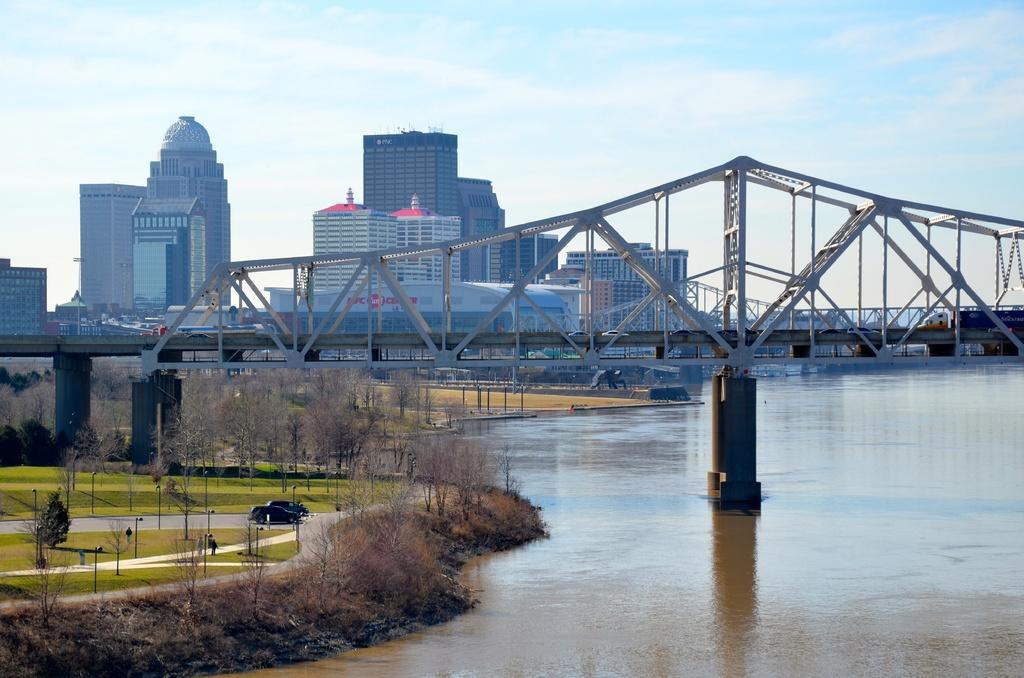Describe this image in one or two sentences. In this picture we can see a bridge, water, poles, trees, buildings and cars on the road and in the background we can see the sky with clouds. 